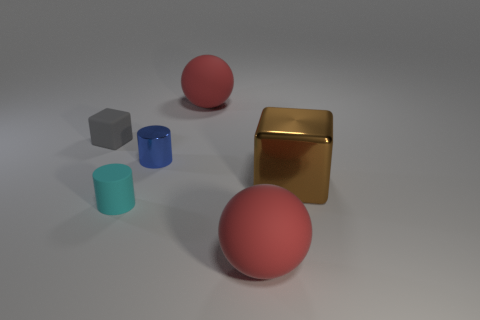Add 3 brown things. How many objects exist? 9 Subtract all balls. How many objects are left? 4 Add 2 brown objects. How many brown objects are left? 3 Add 6 large purple rubber cylinders. How many large purple rubber cylinders exist? 6 Subtract 1 brown blocks. How many objects are left? 5 Subtract all tiny cyan rubber blocks. Subtract all big brown metallic objects. How many objects are left? 5 